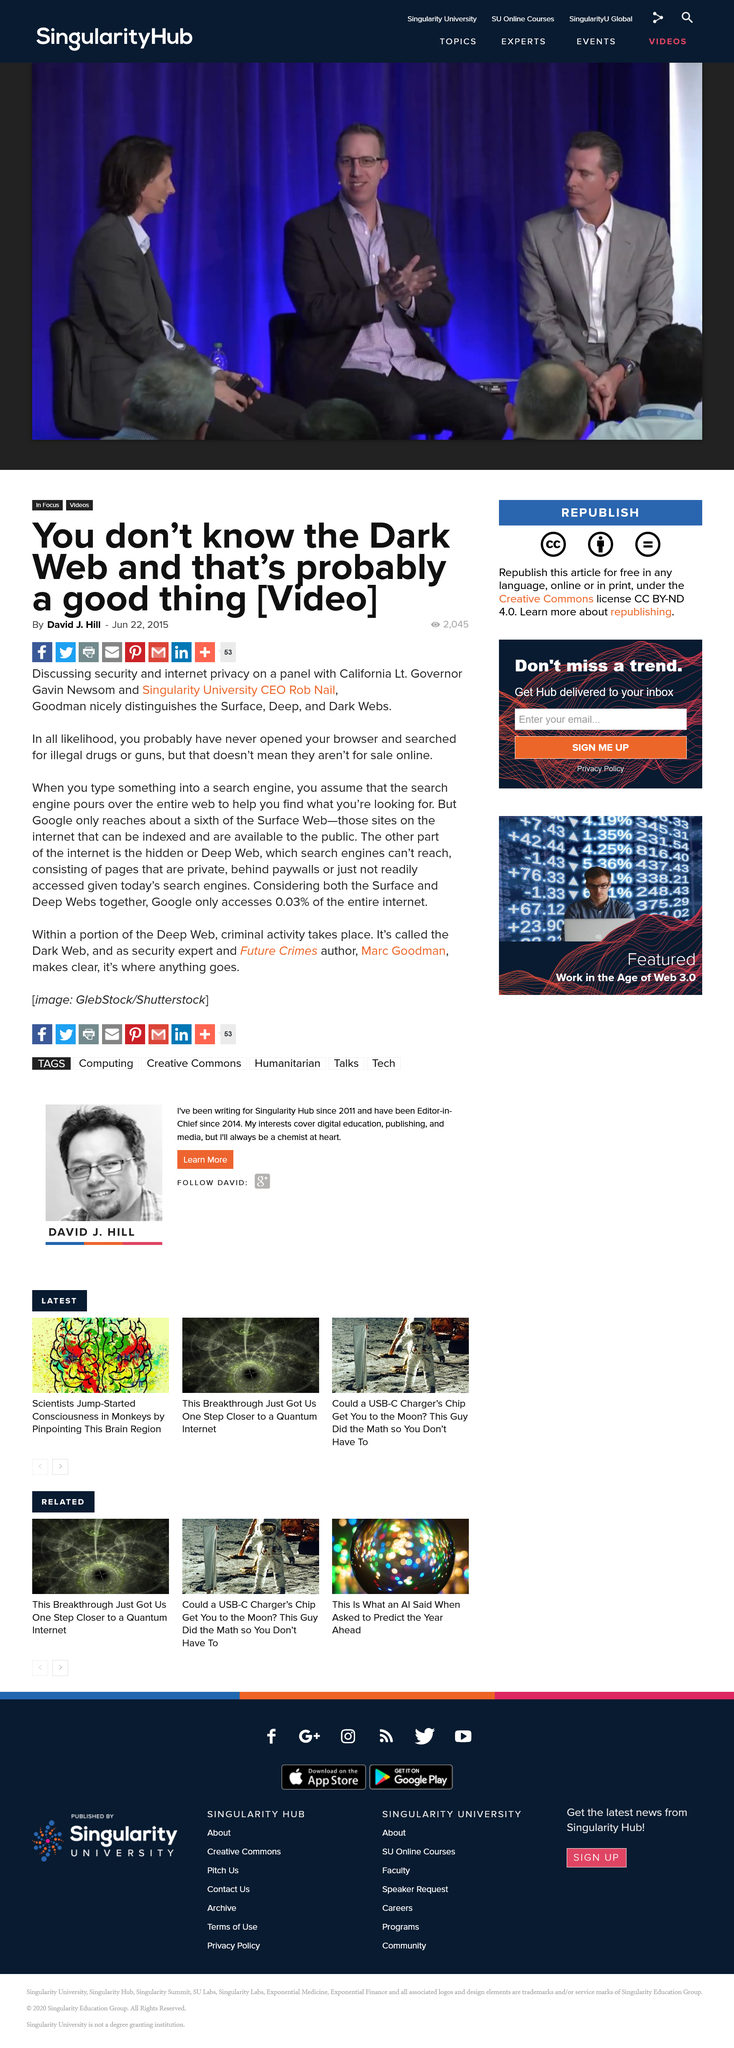Point out several critical features in this image. Google only has access to 0.03% of the internet. Google is only able to access a small portion of the Surface Web, with only about a sixth of it within its reach. The dark web is considered harmful as it is a breeding ground for criminal activities, and these activities are untraceable due to its anonymity, making it a dangerous and risky platform for individuals to engage in. 